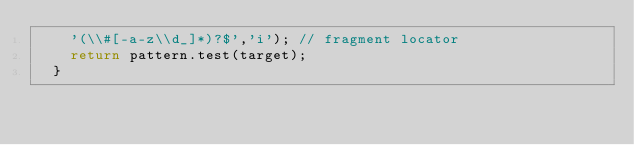Convert code to text. <code><loc_0><loc_0><loc_500><loc_500><_TypeScript_>    '(\\#[-a-z\\d_]*)?$','i'); // fragment locator
    return pattern.test(target);
  }</code> 